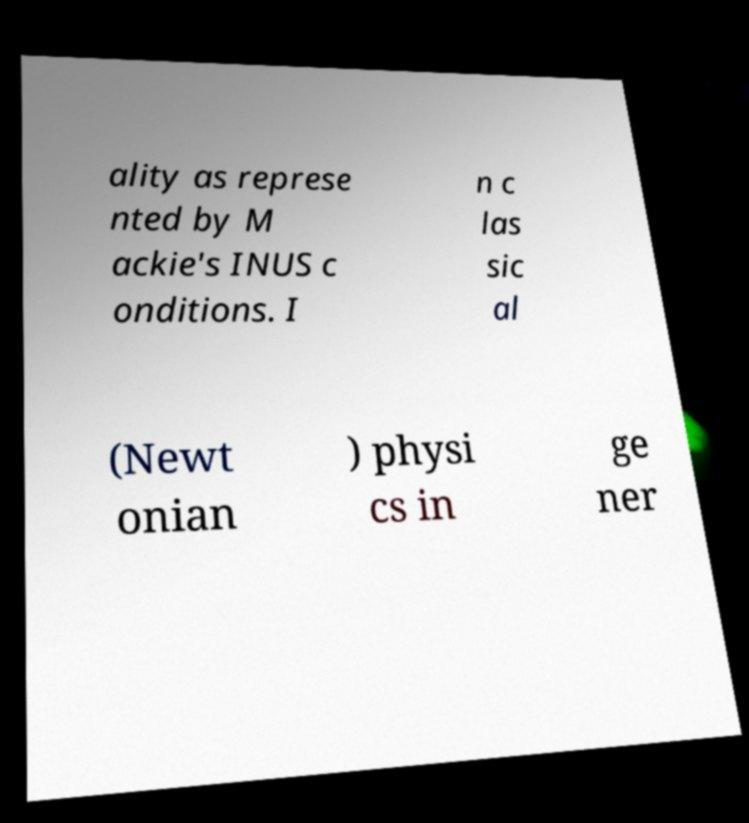There's text embedded in this image that I need extracted. Can you transcribe it verbatim? ality as represe nted by M ackie's INUS c onditions. I n c las sic al (Newt onian ) physi cs in ge ner 